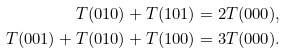Convert formula to latex. <formula><loc_0><loc_0><loc_500><loc_500>T ( 0 1 0 ) + T ( 1 0 1 ) & = 2 T ( 0 0 0 ) , \\ T ( 0 0 1 ) + T ( 0 1 0 ) + T ( 1 0 0 ) & = 3 T ( 0 0 0 ) .</formula> 